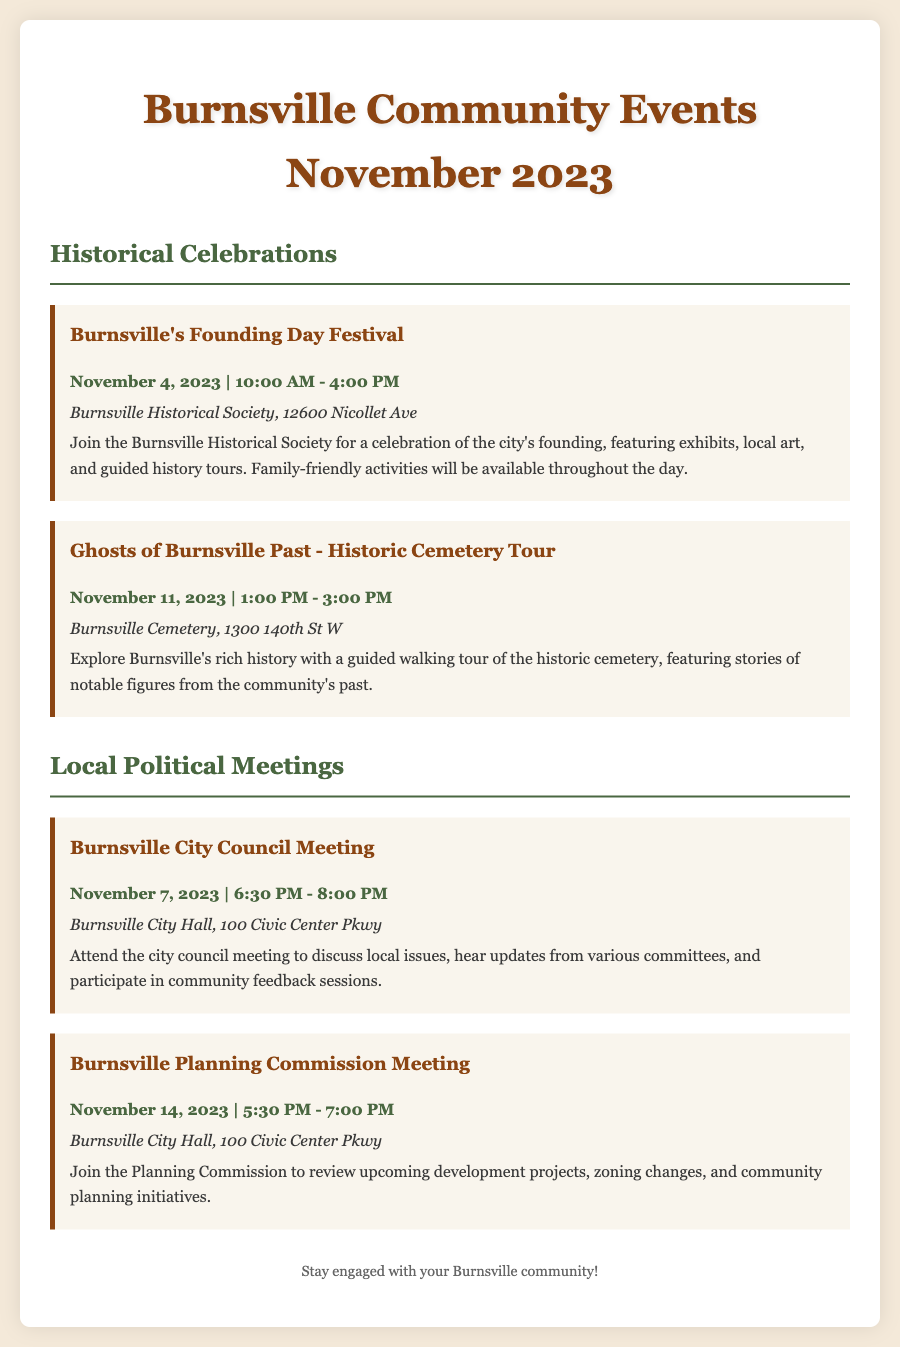What is the date of Burnsville's Founding Day Festival? The Founding Day Festival is scheduled for November 4, 2023.
Answer: November 4, 2023 What time does the Ghosts of Burnsville Past tour start? The walking tour begins at 1:00 PM on November 11, 2023.
Answer: 1:00 PM Where is the Burnsville City Council Meeting held? The city council meeting takes place at Burnsville City Hall, 100 Civic Center Pkwy.
Answer: Burnsville City Hall, 100 Civic Center Pkwy How long does the Burnsville Planning Commission Meeting last? The Planning Commission Meeting lasts from 5:30 PM to 7:00 PM, which is 1.5 hours.
Answer: 1.5 hours What type of activities are offered at the Founding Day Festival? The festival features exhibits, local art, and guided history tours, along with family-friendly activities.
Answer: Exhibits, local art, and guided history tours What is the location of the Ghosts of Burnsville Past tour? The tour will take place at Burnsville Cemetery, located at 1300 140th St W.
Answer: Burnsville Cemetery, 1300 140th St W How often does the City Council Meeting occur? The City Council Meeting is a recurring event that occurs monthly, as indicated by the date.
Answer: Monthly What is a reason for attending the City Council Meeting? Attendees can discuss local issues and hear updates from various committees.
Answer: Discuss local issues and hear updates 